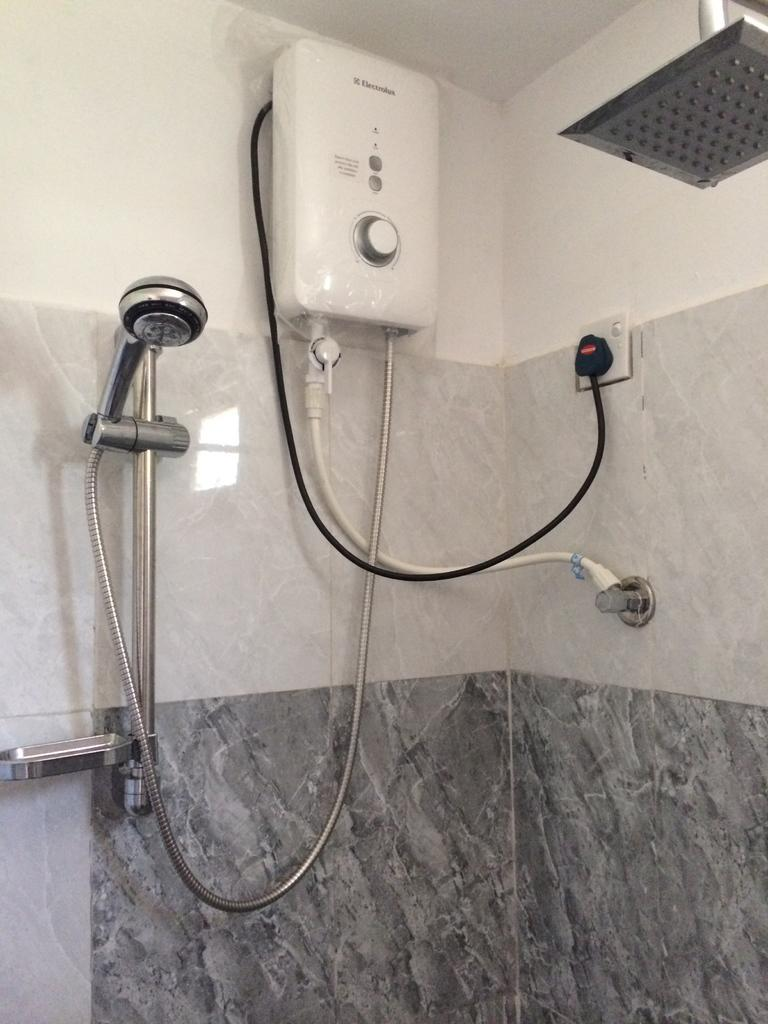What type of structure can be seen in the image? There are walls in the image. What is attached to the walls in the image? There is a pipe, a cable, a shower, a water-heater, a hand-shower, a rod, and a soap holder attached to the walls in the image. What type of punishment is being administered in the image? There is no punishment being administered in the image; it features a shower and other bathroom fixtures. What type of tax is being discussed in the image? There is no discussion of taxes in the image; it focuses on bathroom fixtures and their arrangement. 